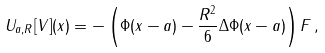<formula> <loc_0><loc_0><loc_500><loc_500>U _ { a , R } [ V ] ( x ) = - \left ( \Phi ( x - a ) - \frac { R ^ { 2 } } { 6 } \Delta \Phi ( x - a ) \right ) F \, ,</formula> 